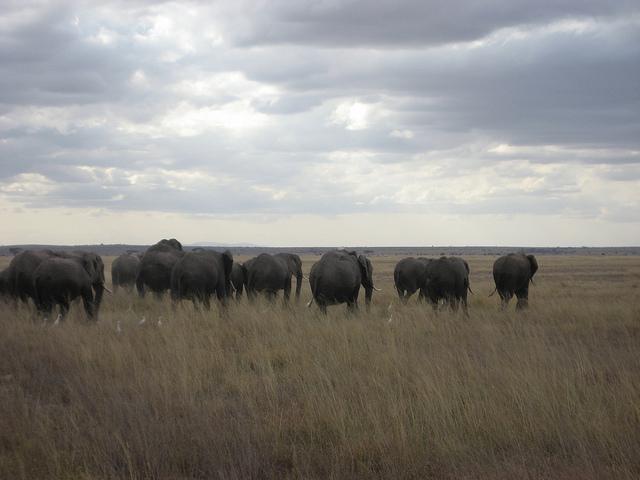Instead of holding hands what can these animals hold when they move together?
Keep it brief. Trunks. What is object sticking up on the right side of the hill in the background?
Quick response, please. Elephant. What sort of animal is in the background?
Give a very brief answer. Elephant. What animals are these?
Write a very short answer. Elephants. What animals are here?
Keep it brief. Elephants. Can you see mountains?
Answer briefly. No. What is in the field with the elephants?
Write a very short answer. Birds. Is there an equine among the animals pictured?
Answer briefly. No. 